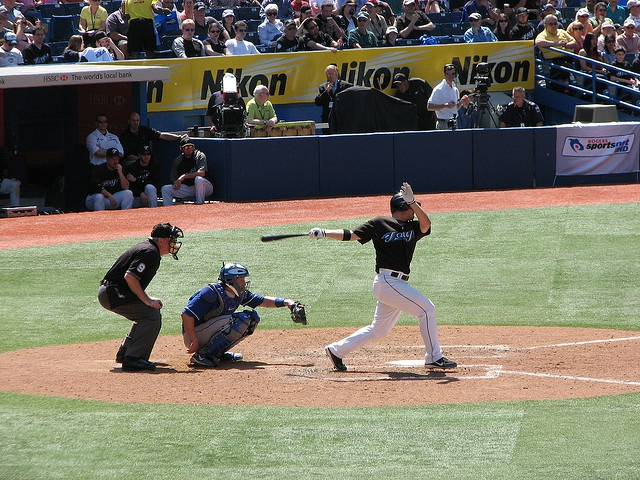Describe the objects in this image and their specific colors. I can see people in purple, black, gray, navy, and maroon tones, people in purple, darkgray, black, gray, and tan tones, people in purple, black, maroon, gray, and darkgray tones, people in purple, black, gray, maroon, and navy tones, and people in purple, black, gray, and maroon tones in this image. 